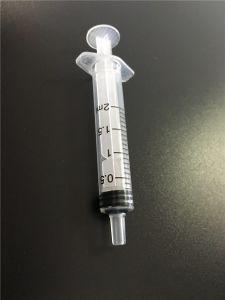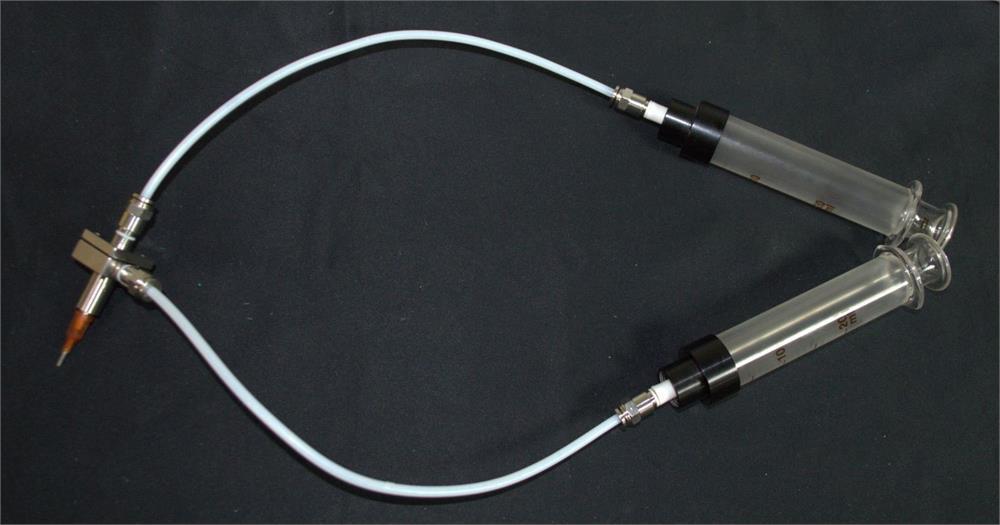The first image is the image on the left, the second image is the image on the right. Evaluate the accuracy of this statement regarding the images: "Each image shows exactly three syringe-related items.". Is it true? Answer yes or no. No. The first image is the image on the left, the second image is the image on the right. For the images displayed, is the sentence "The right image has three syringes." factually correct? Answer yes or no. No. 